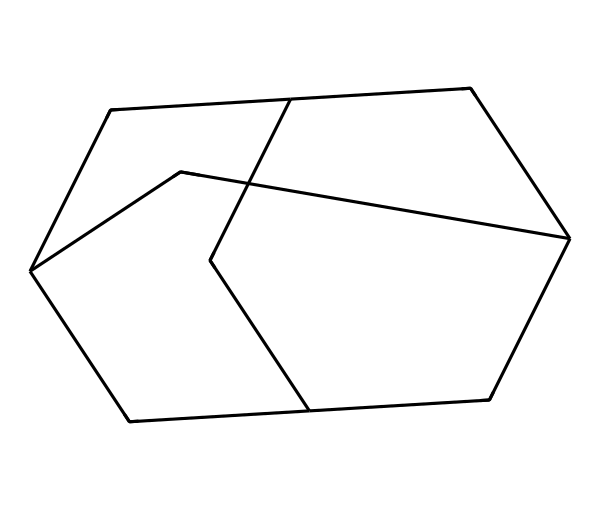What is the molecular formula of adamantane? To determine the molecular formula, we count the number of carbon and hydrogen atoms in the structure. The structure contains 10 carbon atoms and 16 hydrogen atoms. Therefore, the molecular formula is C10H16.
Answer: C10H16 How many rings are present in the structure of adamantane? By analyzing the structure, we can see that there are three interconnected carbon rings forming a cage-like structure in adamantane. Each ring contributes to the overall fused ring system.
Answer: 3 What is the coordination number of the carbon atoms in adamantane? In adamantane, each carbon atom forms four bonds which indicates a coordination number of 4. This is typical for sp3 hybridized carbon atoms in such saturated structures.
Answer: 4 What type of hybridization do the carbon atoms in adamantane undergo? The carbon atoms in adamantane each use sp3 hybridization due to the four single bonds formed with other carbon and hydrogen atoms in its structure.
Answer: sp3 What structural feature distinguishes adamantane as a cage compound? Adamantane’s unique characteristic is its three-dimensional arrangement of carbon atoms forming a closed polyhedral shape, resembling a cage. This feature is essential for classifying it as a cage compound.
Answer: closed polyhedral shape How many hydrogen atoms are directly bonded to the outer carbon atoms of adamantane? In the adamantane structure, the outer carbon atoms (which make up the cage) each have two hydrogen atoms attached, giving a total of 8 hydrogen atoms bonded to the outer carbons (4 outer carbons * 2).
Answer: 8 